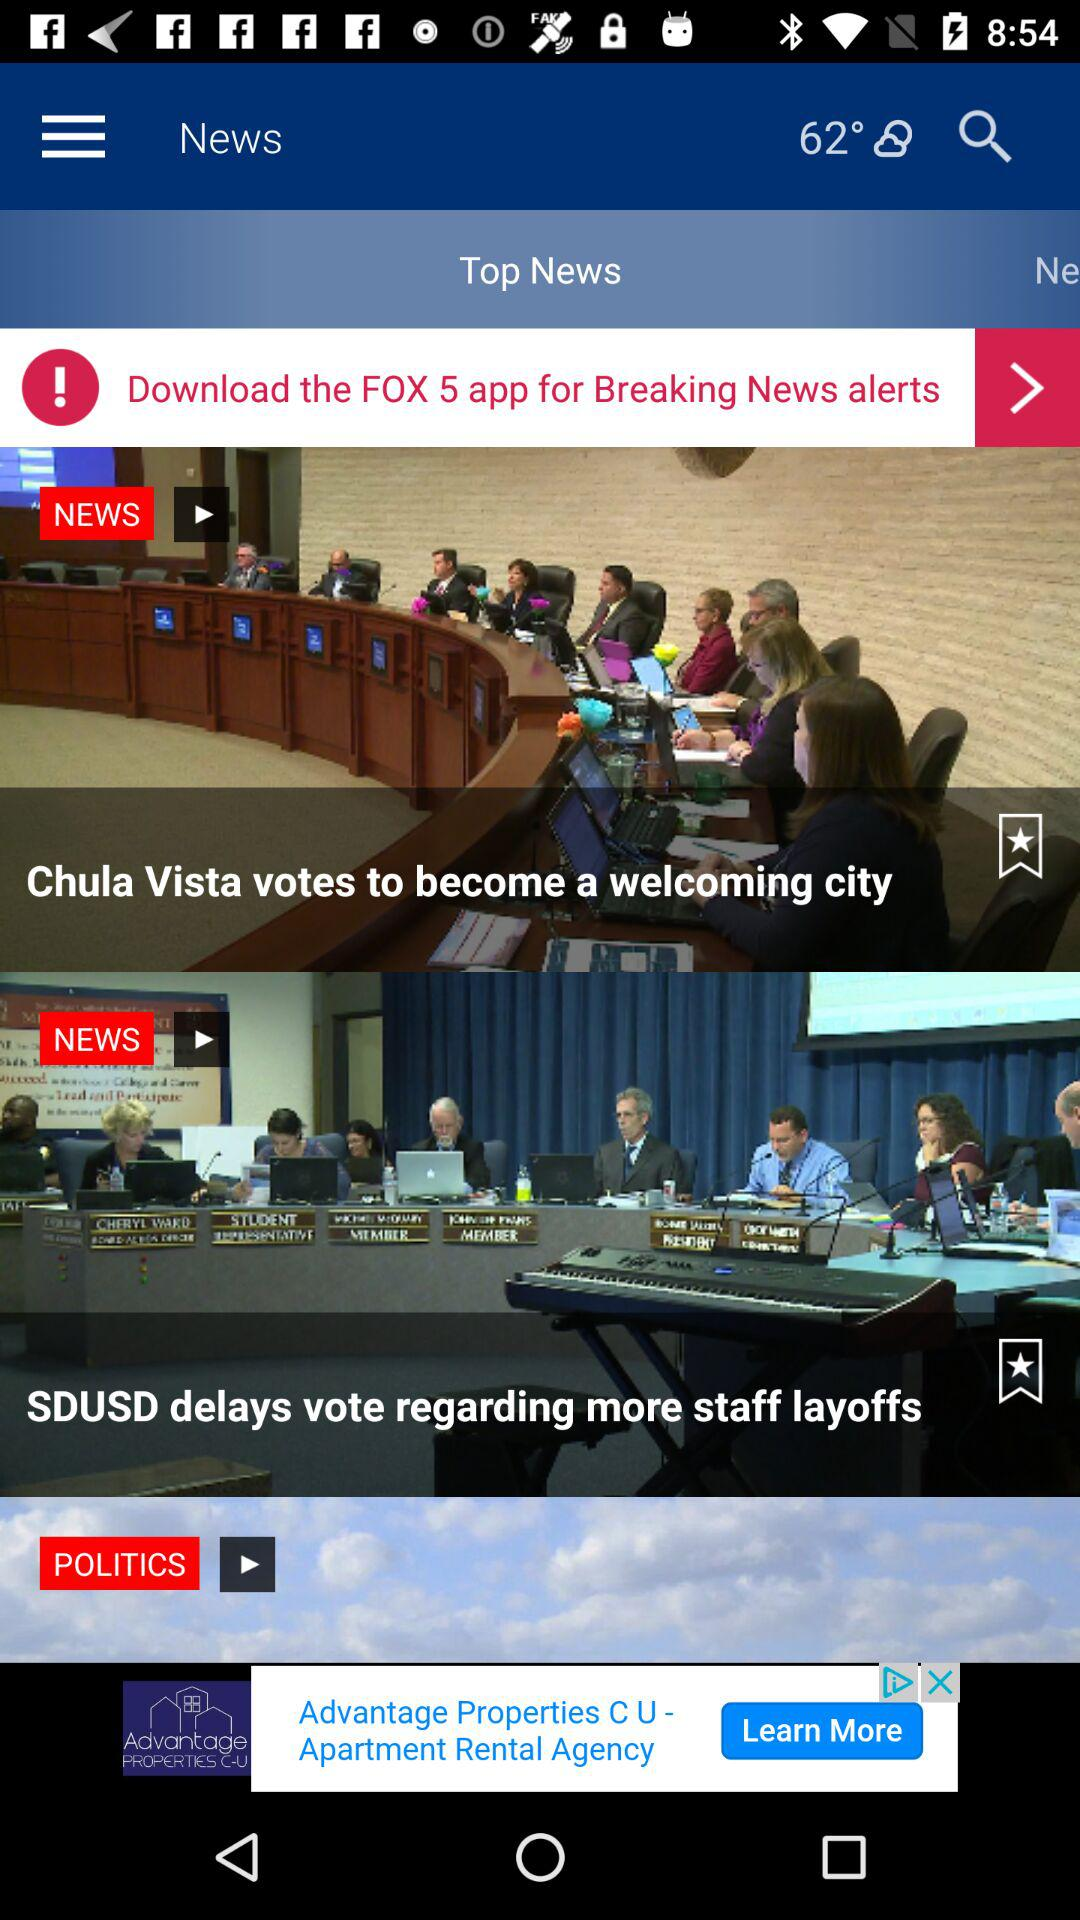What is the temperature? The temperature is 62°. 